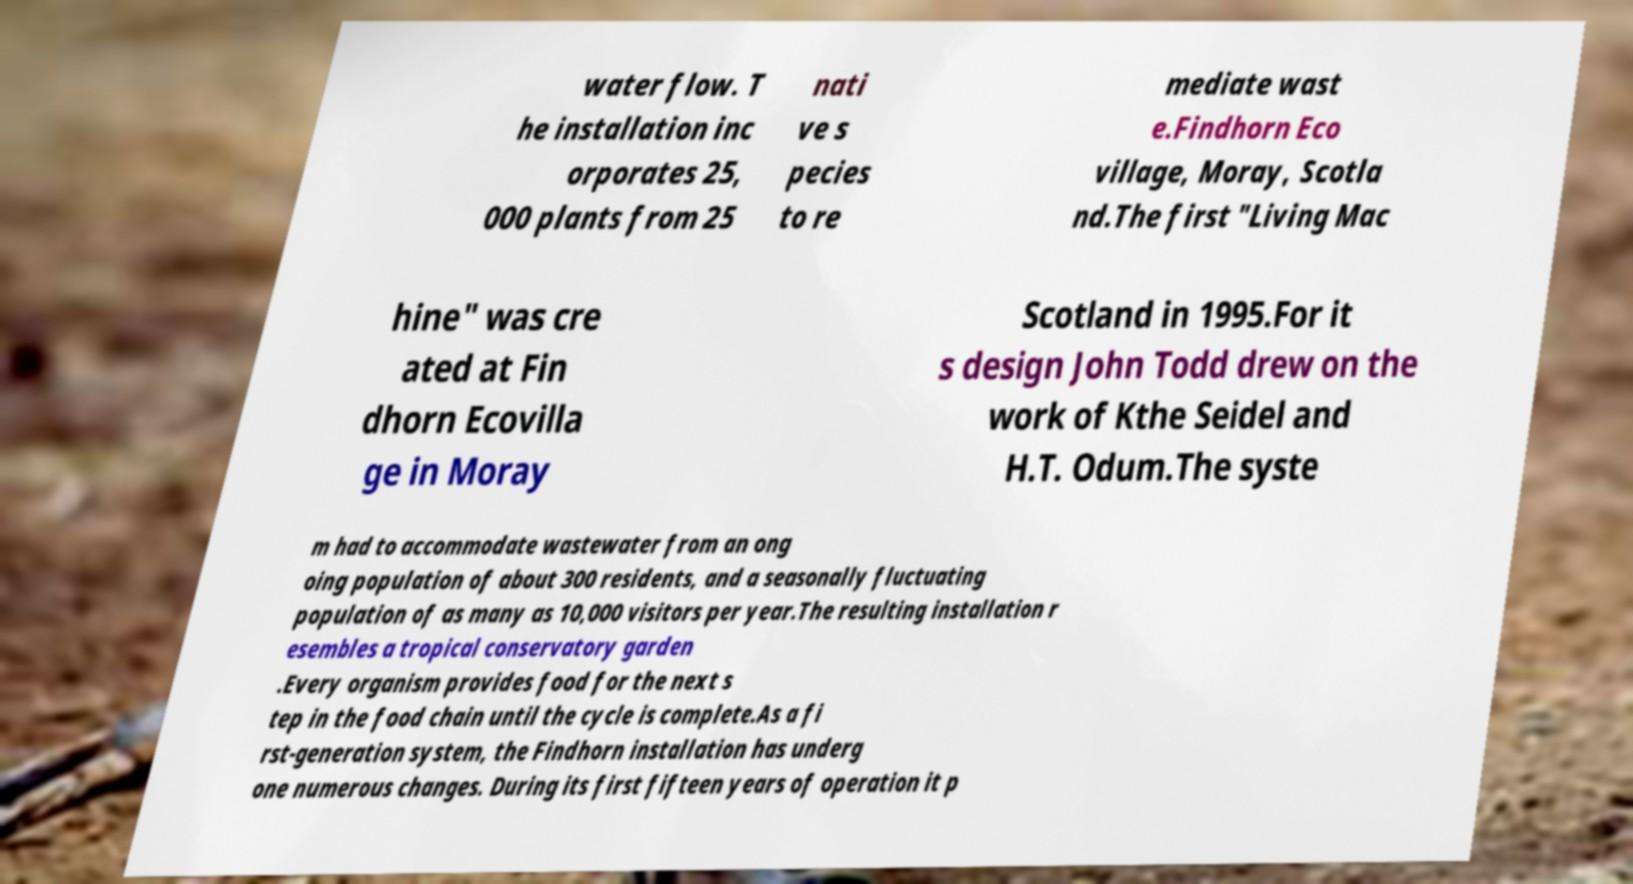Please identify and transcribe the text found in this image. water flow. T he installation inc orporates 25, 000 plants from 25 nati ve s pecies to re mediate wast e.Findhorn Eco village, Moray, Scotla nd.The first "Living Mac hine" was cre ated at Fin dhorn Ecovilla ge in Moray Scotland in 1995.For it s design John Todd drew on the work of Kthe Seidel and H.T. Odum.The syste m had to accommodate wastewater from an ong oing population of about 300 residents, and a seasonally fluctuating population of as many as 10,000 visitors per year.The resulting installation r esembles a tropical conservatory garden .Every organism provides food for the next s tep in the food chain until the cycle is complete.As a fi rst-generation system, the Findhorn installation has underg one numerous changes. During its first fifteen years of operation it p 